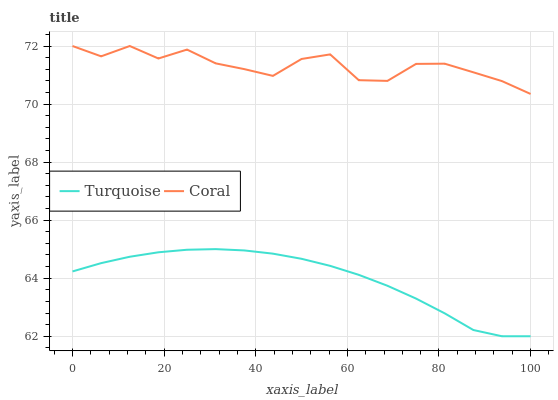Does Turquoise have the minimum area under the curve?
Answer yes or no. Yes. Does Coral have the maximum area under the curve?
Answer yes or no. Yes. Does Coral have the minimum area under the curve?
Answer yes or no. No. Is Turquoise the smoothest?
Answer yes or no. Yes. Is Coral the roughest?
Answer yes or no. Yes. Is Coral the smoothest?
Answer yes or no. No. Does Turquoise have the lowest value?
Answer yes or no. Yes. Does Coral have the lowest value?
Answer yes or no. No. Does Coral have the highest value?
Answer yes or no. Yes. Is Turquoise less than Coral?
Answer yes or no. Yes. Is Coral greater than Turquoise?
Answer yes or no. Yes. Does Turquoise intersect Coral?
Answer yes or no. No. 